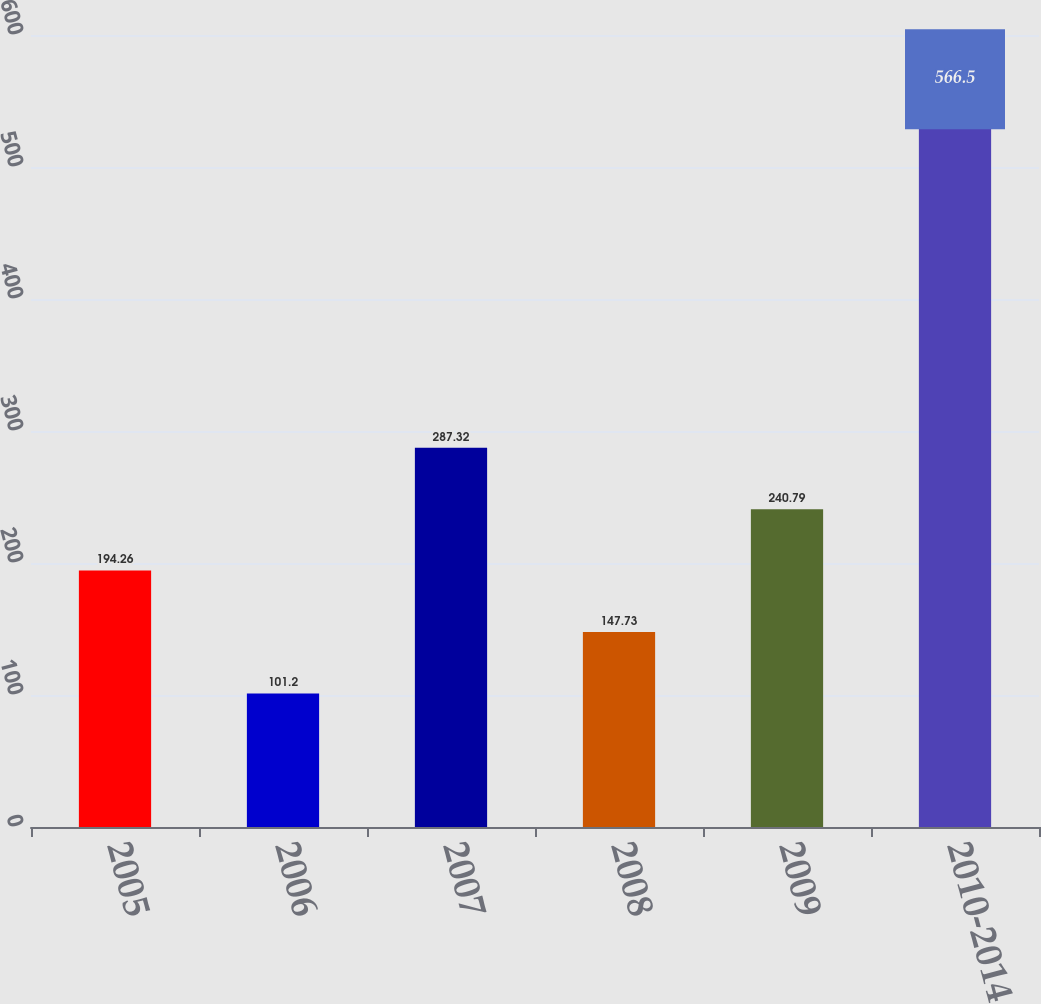<chart> <loc_0><loc_0><loc_500><loc_500><bar_chart><fcel>2005<fcel>2006<fcel>2007<fcel>2008<fcel>2009<fcel>2010-2014<nl><fcel>194.26<fcel>101.2<fcel>287.32<fcel>147.73<fcel>240.79<fcel>566.5<nl></chart> 